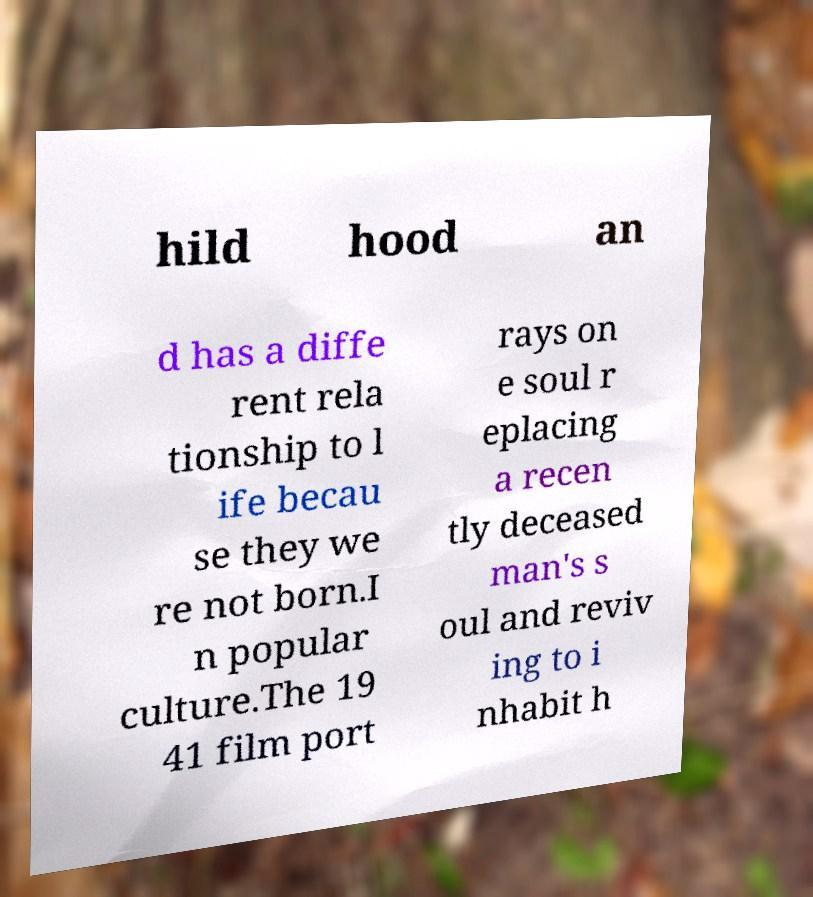What messages or text are displayed in this image? I need them in a readable, typed format. hild hood an d has a diffe rent rela tionship to l ife becau se they we re not born.I n popular culture.The 19 41 film port rays on e soul r eplacing a recen tly deceased man's s oul and reviv ing to i nhabit h 